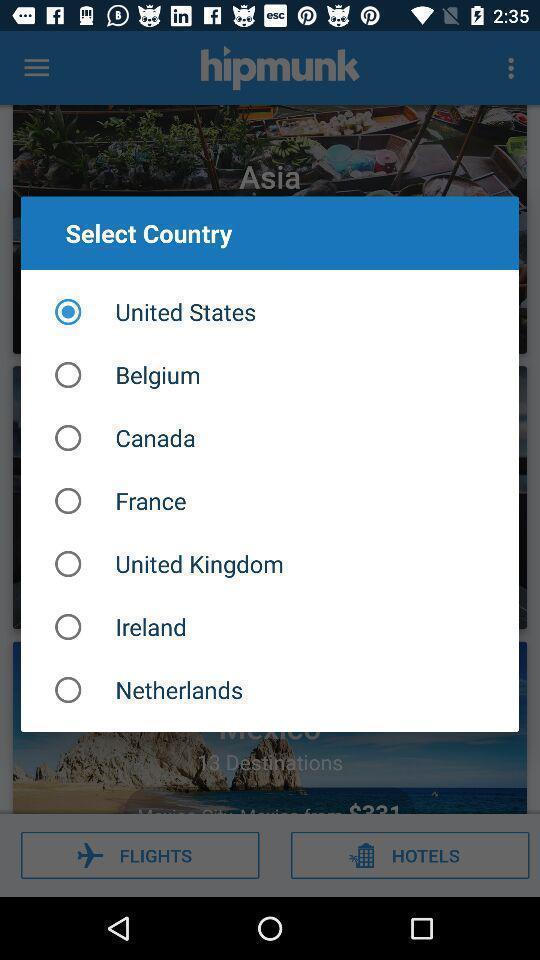Explain the elements present in this screenshot. Pop-up shows list of countries in a travel app. 